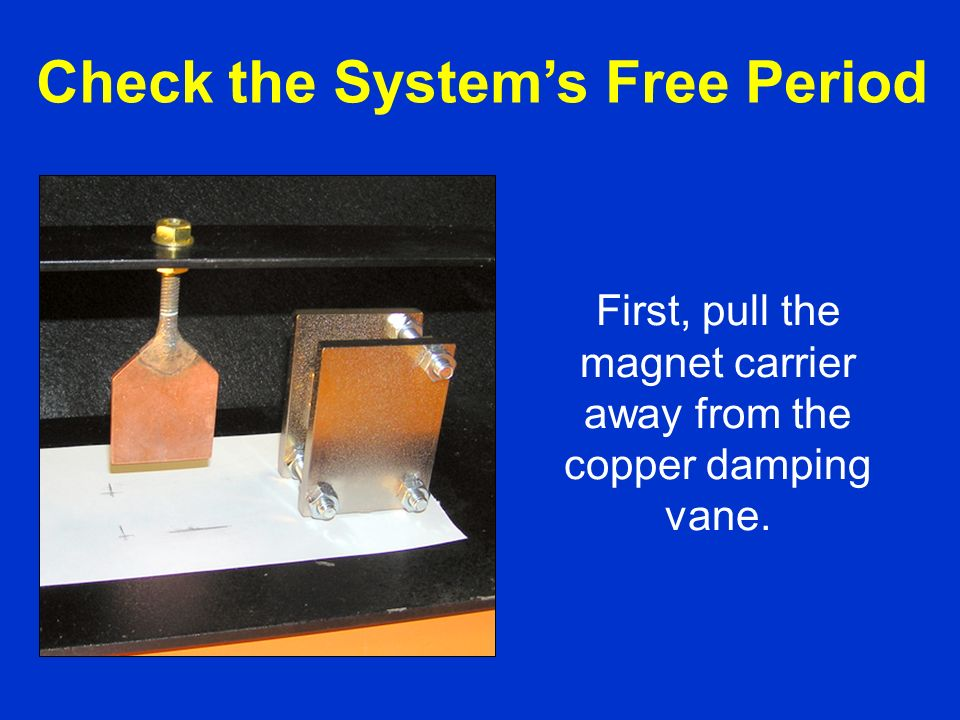Imagine if this setup were scaled up to replace the copper vane with a large metal plate. How might this be used in real-world applications? Scaling up this setup with a larger metal plate could lead to numerous real-world applications, particularly in areas requiring controlled motion or vibration damping. For example, in high-speed trains, large metal damping systems are used to smooth out vibrations and reduce oscillations, thereby enhancing ride comfort and structural integrity. Similarly, in elevators, braking systems utilize large-scale magnetic damping to ensure smooth and controlled descent. This principle can also be applied in wind turbines to stabilize the rotational speeds of the blades, preventing mechanical strain and potential damage. Overall, the scaled-up version of this experiment could significantly improve safety, efficiency, and operational life in various engineering systems.  Could this principle be applied in futuristic space travel technologies? Yes, the principle of magnetic damping could be critically beneficial in the realm of futuristic space travel technologies. For instance, in spacecraft stabilization systems, magnetic damping can help mitigate mechanical vibrations and oscillations caused by external forces like micro-meteoroid impacts or thruster firings. This enhancement can protect sensitive instruments and structural components, ensuring more reliable mission operations. Additionally, in space habitats, magnetic damping systems can be employed to stabilize rotating sections, providing consistent artificial gravity levels for crew members. Furthermore, advances in magnetic damping could pave the way for innovative launch and reentry systems, where such technology might be used to control descent speeds more precisely, achieving safer and more efficient space missions. 